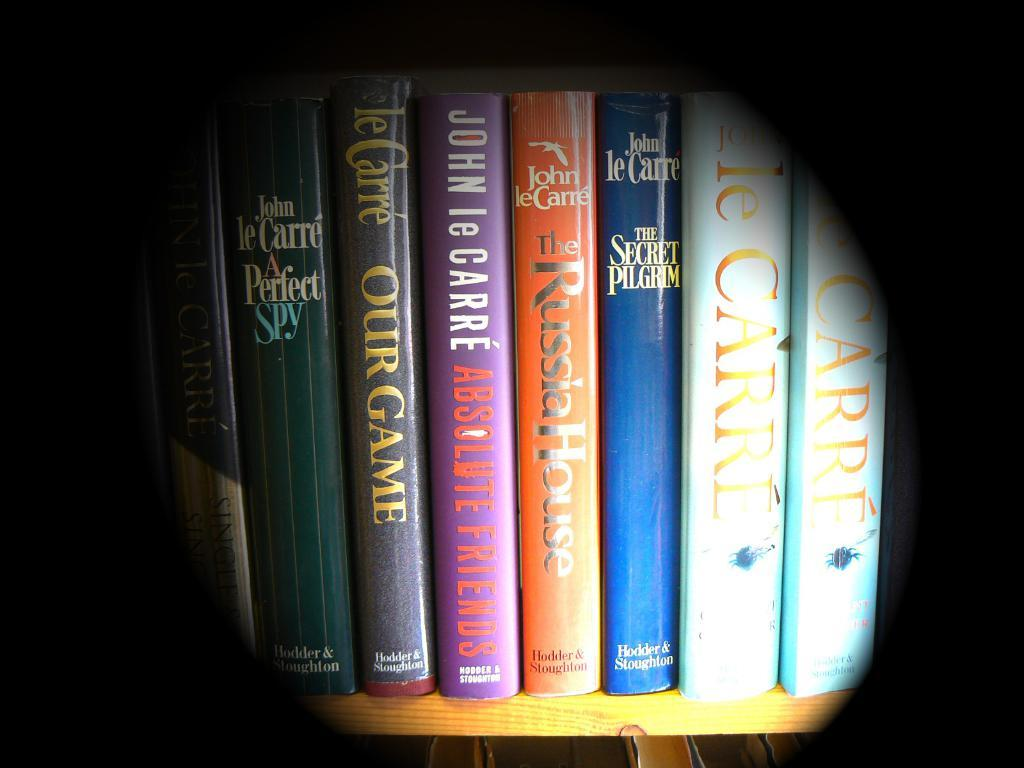Provide a one-sentence caption for the provided image. The image shows a shelf of books that have the genre of thrillers, espionage and mysteries. 